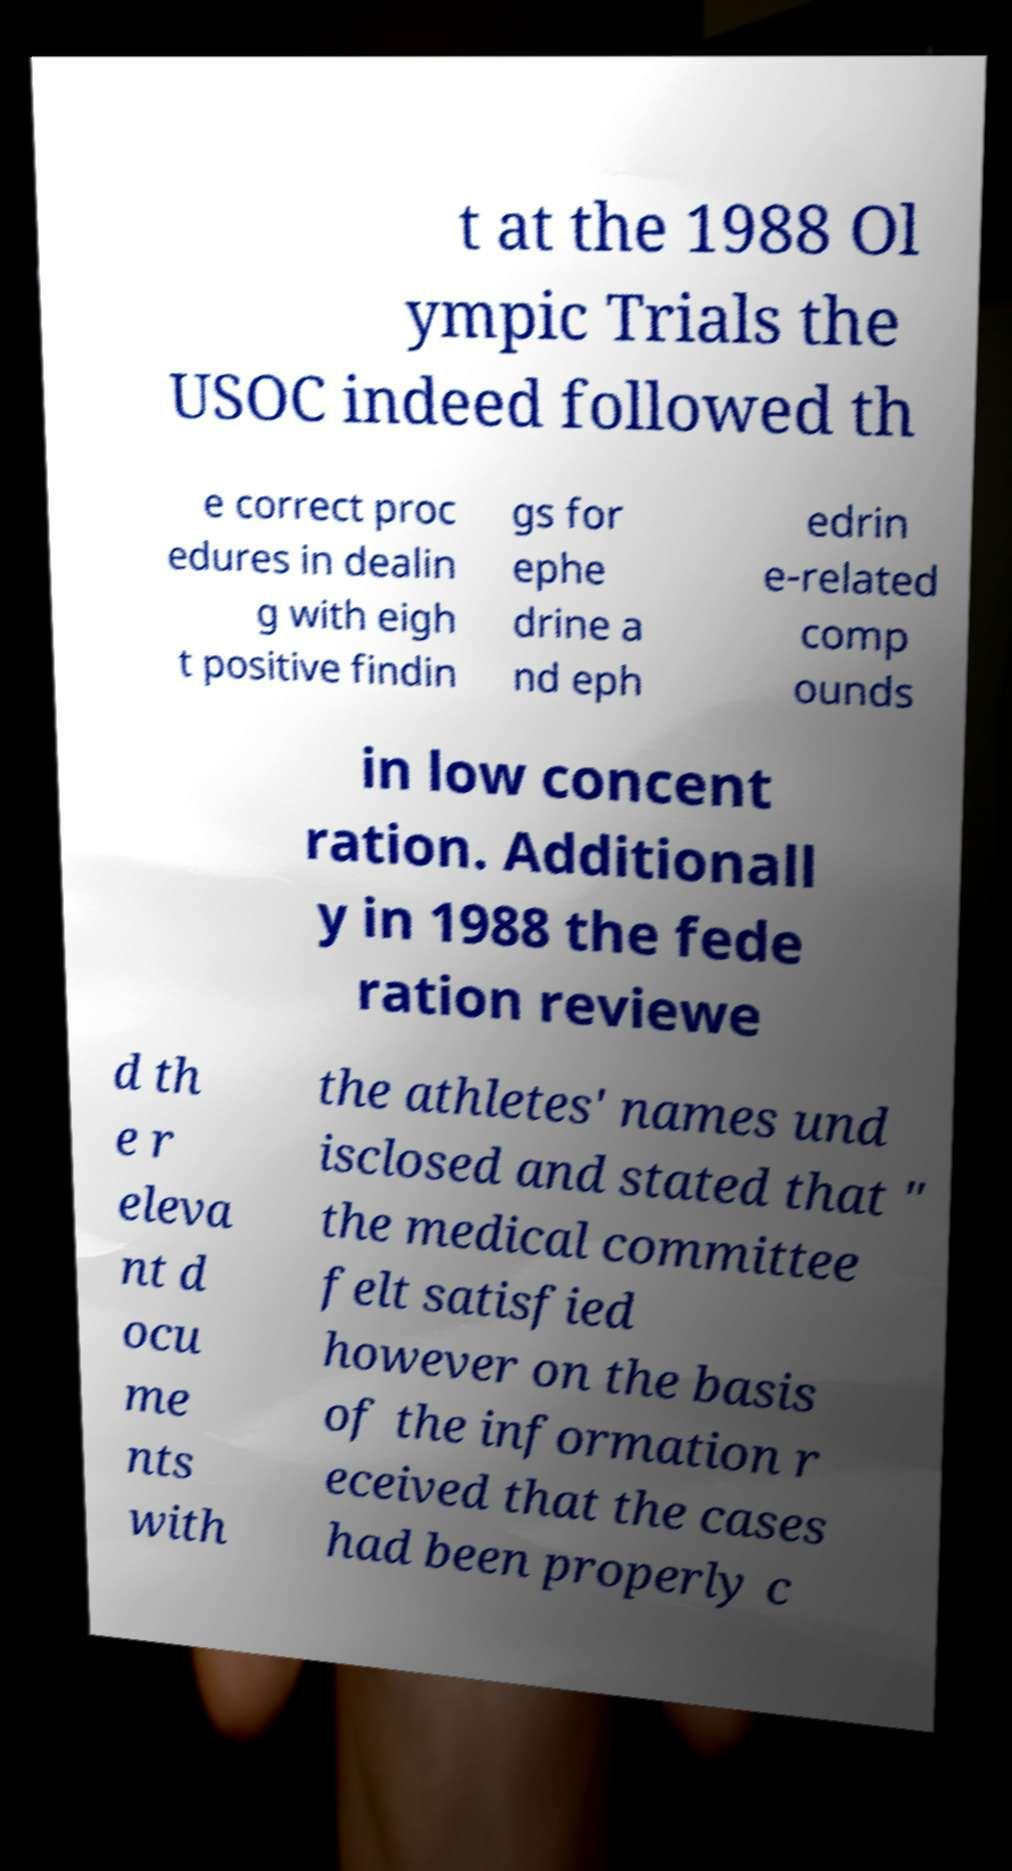Can you read and provide the text displayed in the image?This photo seems to have some interesting text. Can you extract and type it out for me? t at the 1988 Ol ympic Trials the USOC indeed followed th e correct proc edures in dealin g with eigh t positive findin gs for ephe drine a nd eph edrin e-related comp ounds in low concent ration. Additionall y in 1988 the fede ration reviewe d th e r eleva nt d ocu me nts with the athletes' names und isclosed and stated that " the medical committee felt satisfied however on the basis of the information r eceived that the cases had been properly c 